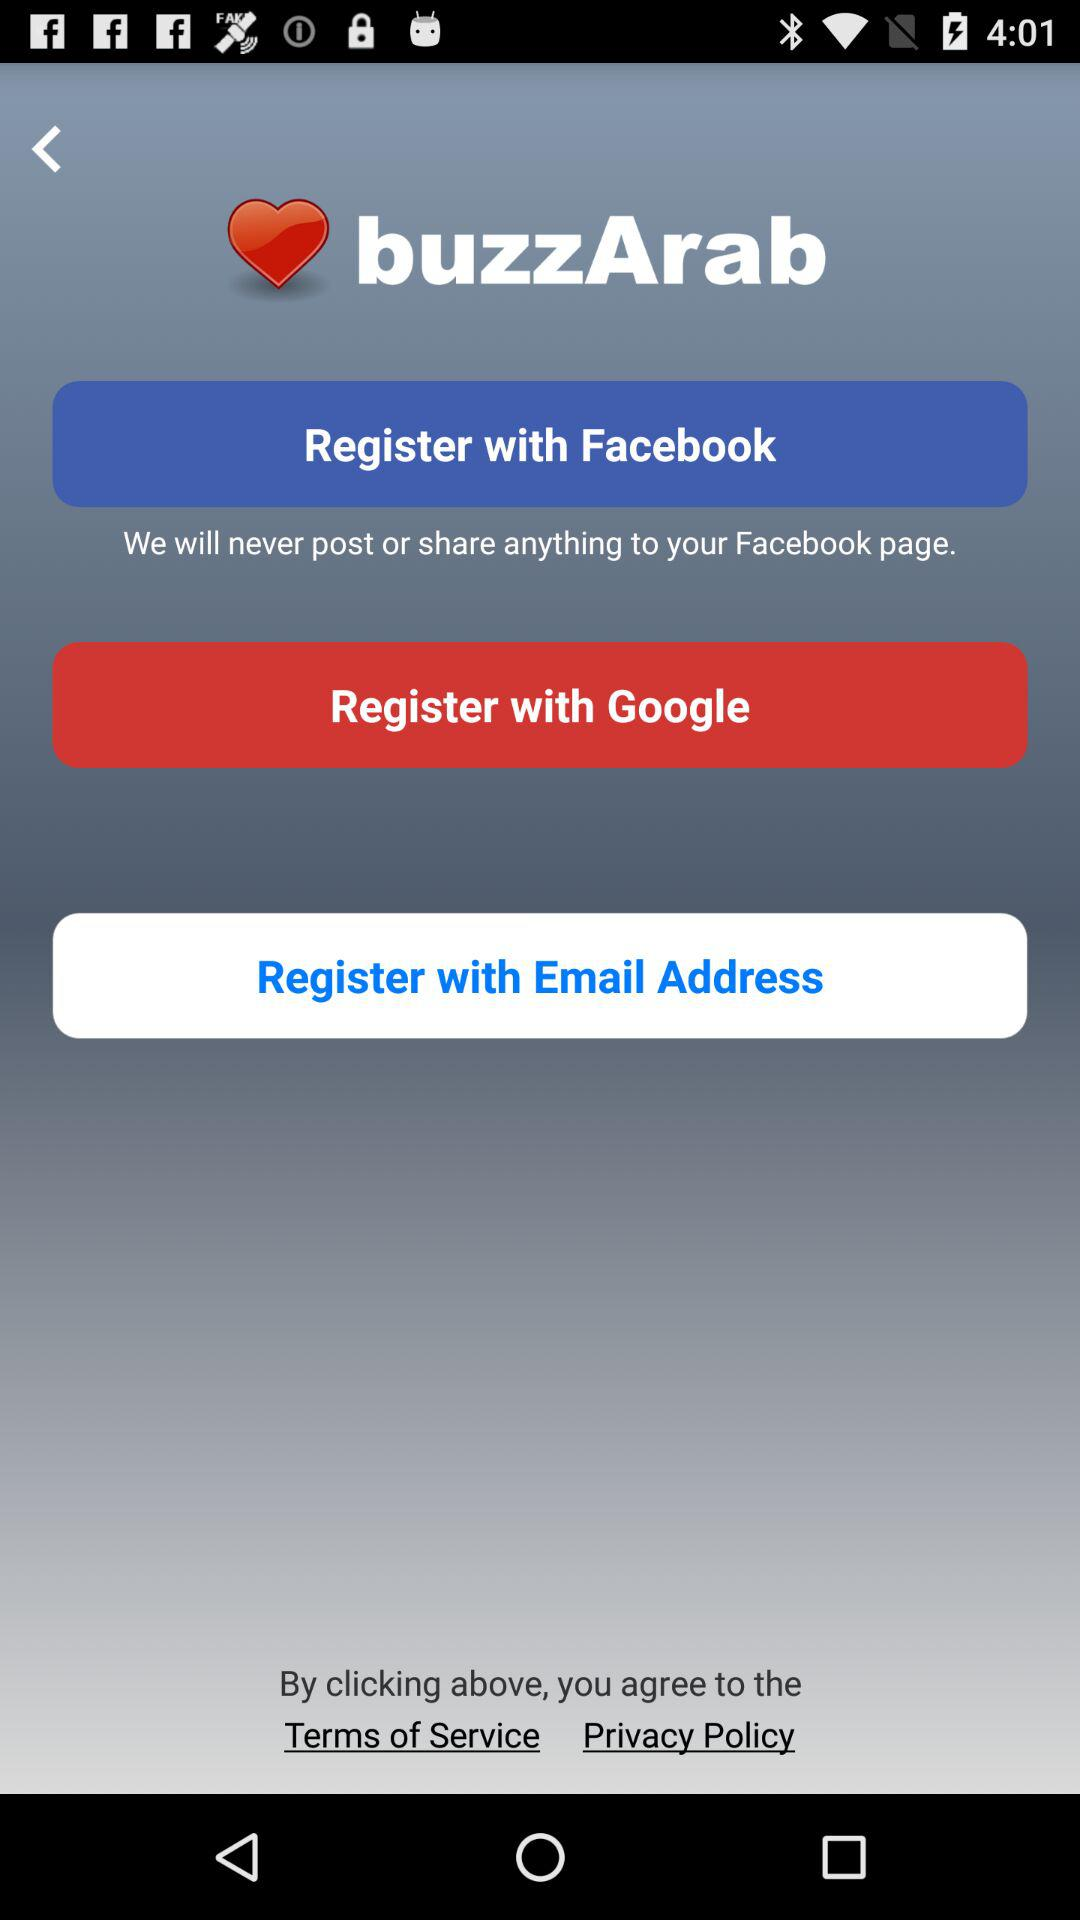How many registration options do you have?
Answer the question using a single word or phrase. 3 